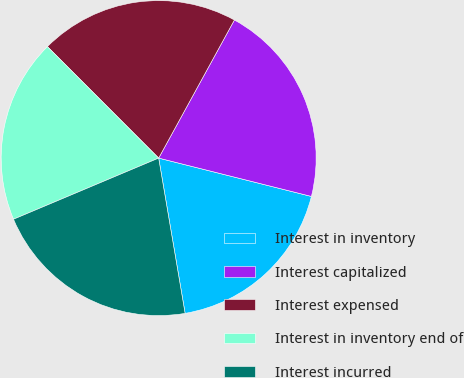Convert chart to OTSL. <chart><loc_0><loc_0><loc_500><loc_500><pie_chart><fcel>Interest in inventory<fcel>Interest capitalized<fcel>Interest expensed<fcel>Interest in inventory end of<fcel>Interest incurred<nl><fcel>18.4%<fcel>20.93%<fcel>20.47%<fcel>18.86%<fcel>21.34%<nl></chart> 